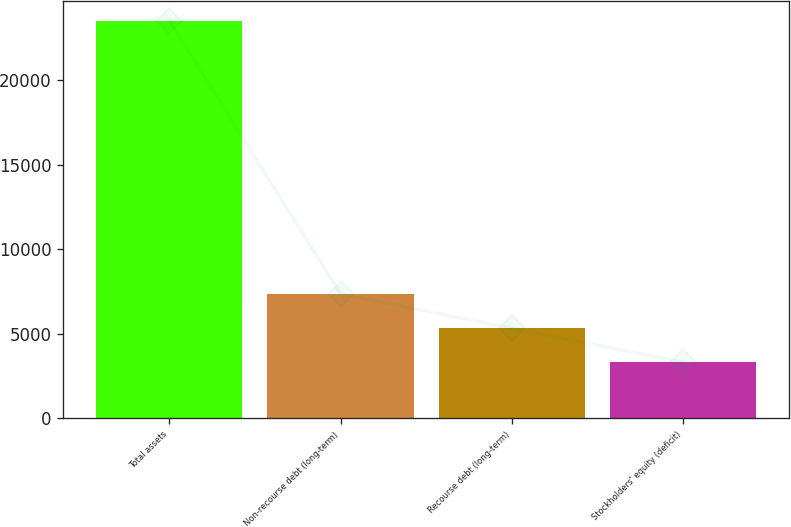<chart> <loc_0><loc_0><loc_500><loc_500><bar_chart><fcel>Total assets<fcel>Non-recourse debt (long-term)<fcel>Recourse debt (long-term)<fcel>Stockholders' equity (deficit)<nl><fcel>23537<fcel>7359.4<fcel>5337.2<fcel>3315<nl></chart> 